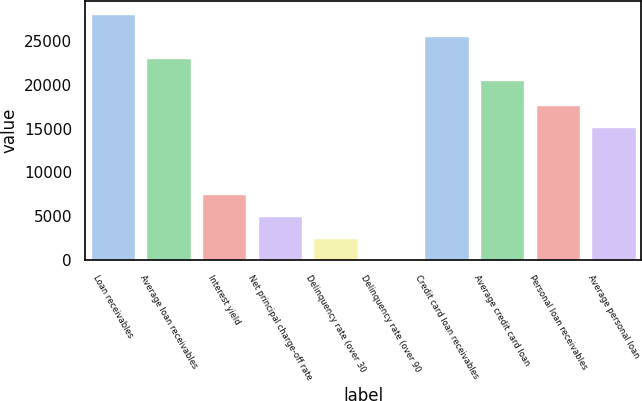<chart> <loc_0><loc_0><loc_500><loc_500><bar_chart><fcel>Loan receivables<fcel>Average loan receivables<fcel>Interest yield<fcel>Net principal charge-off rate<fcel>Delinquency rate (over 30<fcel>Delinquency rate (over 90<fcel>Credit card loan receivables<fcel>Average credit card loan<fcel>Personal loan receivables<fcel>Average personal loan<nl><fcel>28131.5<fcel>23088.5<fcel>7566.53<fcel>5045.04<fcel>2523.55<fcel>2.06<fcel>25610<fcel>20567<fcel>17652.5<fcel>15131<nl></chart> 